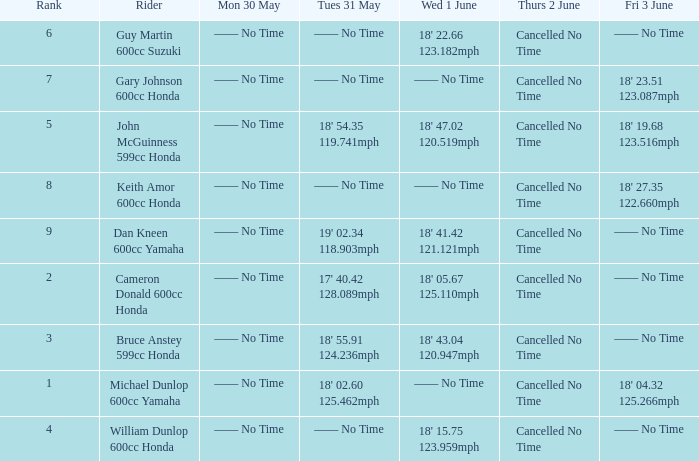What is the Fri 3 June time for the rider with a Weds 1 June time of 18' 22.66 123.182mph? —— No Time. 